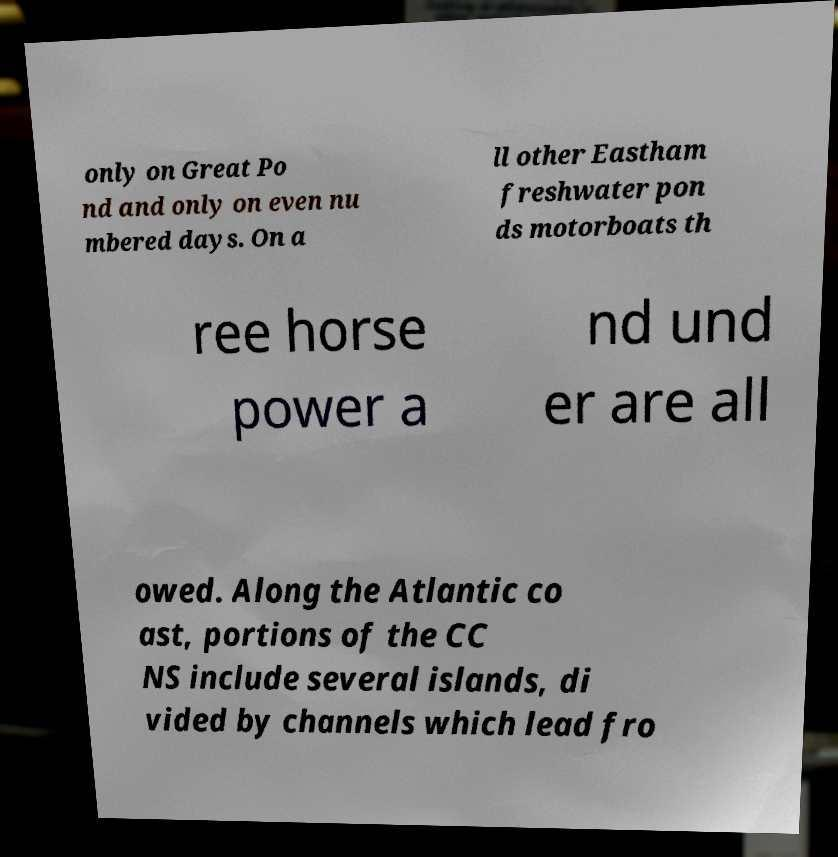Can you accurately transcribe the text from the provided image for me? only on Great Po nd and only on even nu mbered days. On a ll other Eastham freshwater pon ds motorboats th ree horse power a nd und er are all owed. Along the Atlantic co ast, portions of the CC NS include several islands, di vided by channels which lead fro 